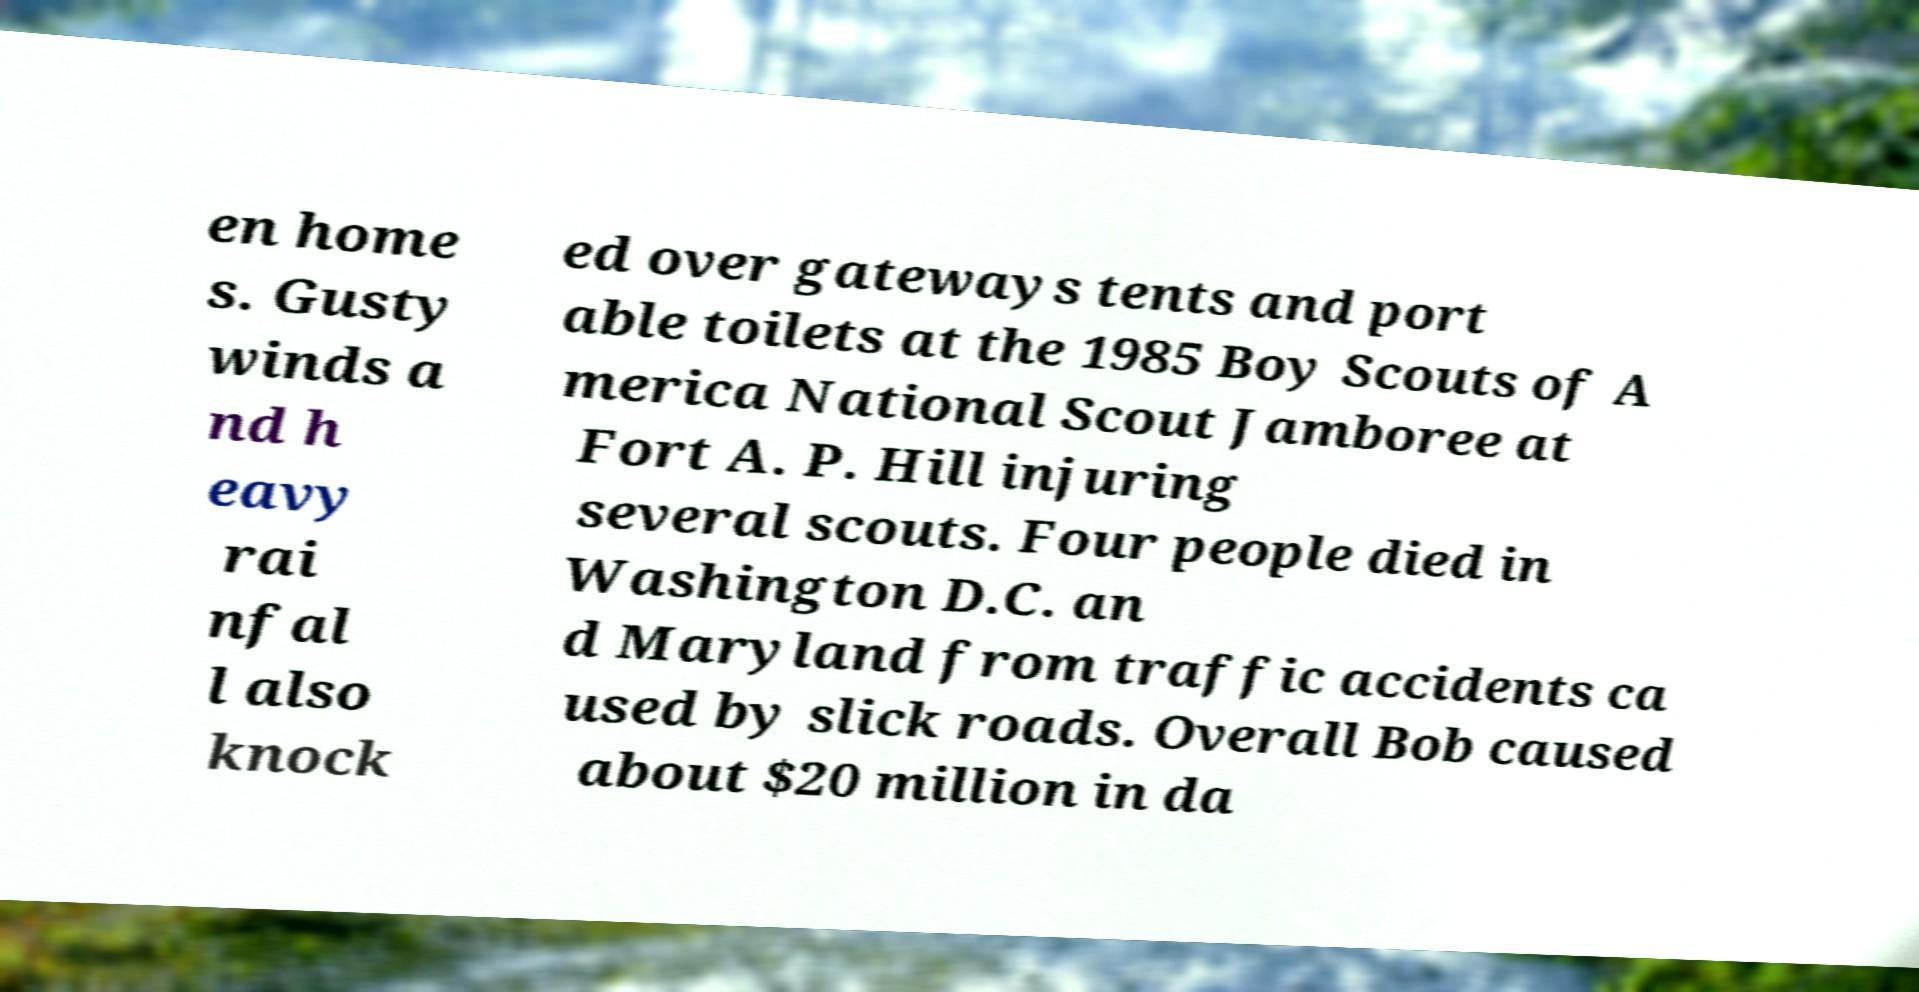Please identify and transcribe the text found in this image. en home s. Gusty winds a nd h eavy rai nfal l also knock ed over gateways tents and port able toilets at the 1985 Boy Scouts of A merica National Scout Jamboree at Fort A. P. Hill injuring several scouts. Four people died in Washington D.C. an d Maryland from traffic accidents ca used by slick roads. Overall Bob caused about $20 million in da 